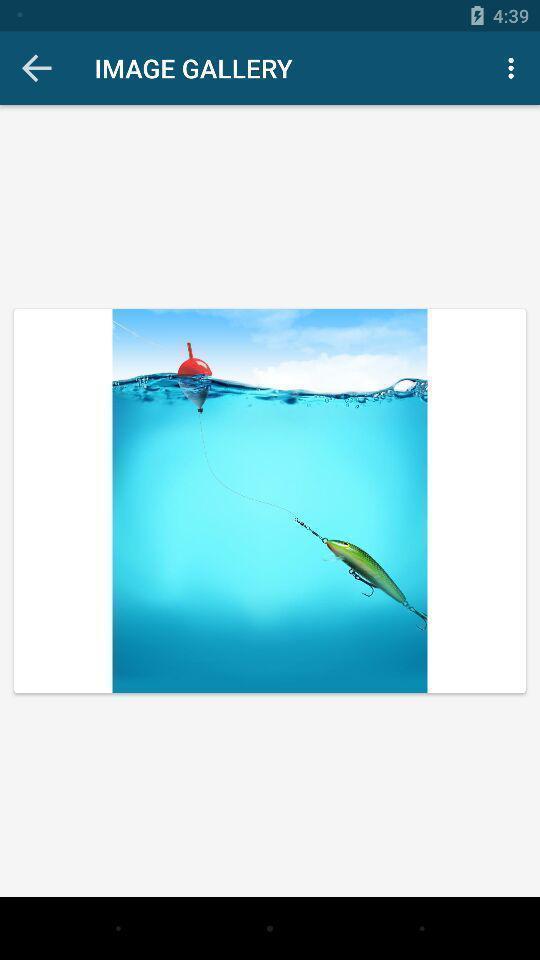Describe the key features of this screenshot. Screen showing an image. 